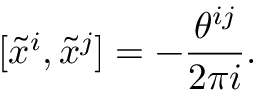Convert formula to latex. <formula><loc_0><loc_0><loc_500><loc_500>[ \tilde { x } ^ { i } , \tilde { x } ^ { j } ] = - \frac { \theta ^ { i j } } { 2 \pi i } .</formula> 